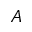<formula> <loc_0><loc_0><loc_500><loc_500>A</formula> 